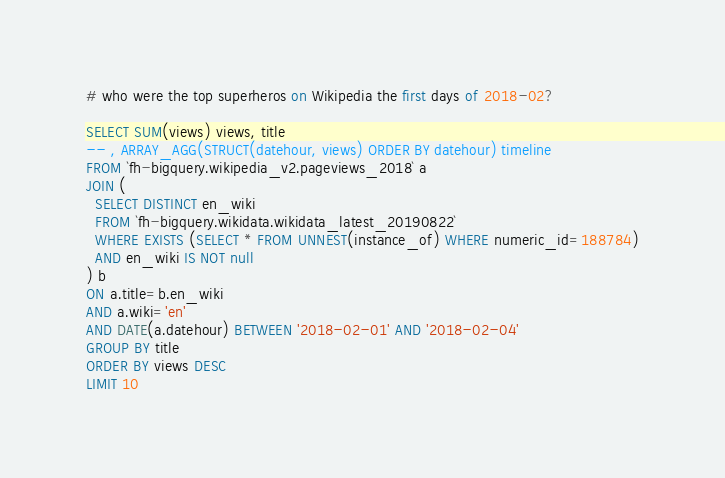Convert code to text. <code><loc_0><loc_0><loc_500><loc_500><_SQL_># who were the top superheros on Wikipedia the first days of 2018-02?

SELECT SUM(views) views, title
-- , ARRAY_AGG(STRUCT(datehour, views) ORDER BY datehour) timeline
FROM `fh-bigquery.wikipedia_v2.pageviews_2018` a
JOIN (
  SELECT DISTINCT en_wiki 
  FROM `fh-bigquery.wikidata.wikidata_latest_20190822` 
  WHERE EXISTS (SELECT * FROM UNNEST(instance_of) WHERE numeric_id=188784)
  AND en_wiki IS NOT null 
) b
ON a.title=b.en_wiki
AND a.wiki='en'
AND DATE(a.datehour) BETWEEN '2018-02-01' AND '2018-02-04'
GROUP BY title
ORDER BY views DESC
LIMIT 10
</code> 